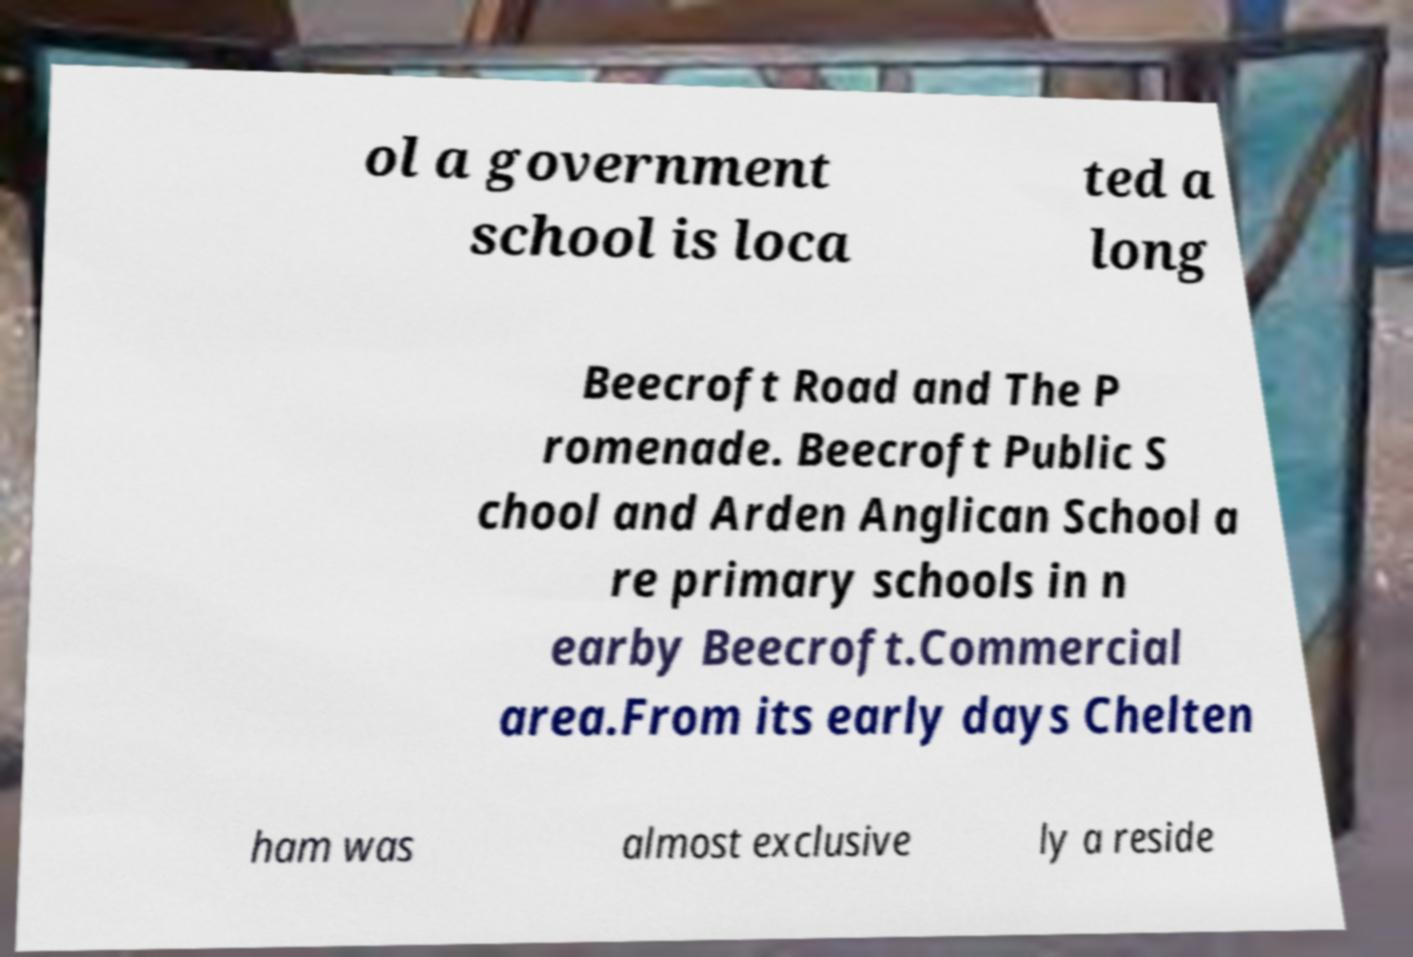Can you accurately transcribe the text from the provided image for me? ol a government school is loca ted a long Beecroft Road and The P romenade. Beecroft Public S chool and Arden Anglican School a re primary schools in n earby Beecroft.Commercial area.From its early days Chelten ham was almost exclusive ly a reside 